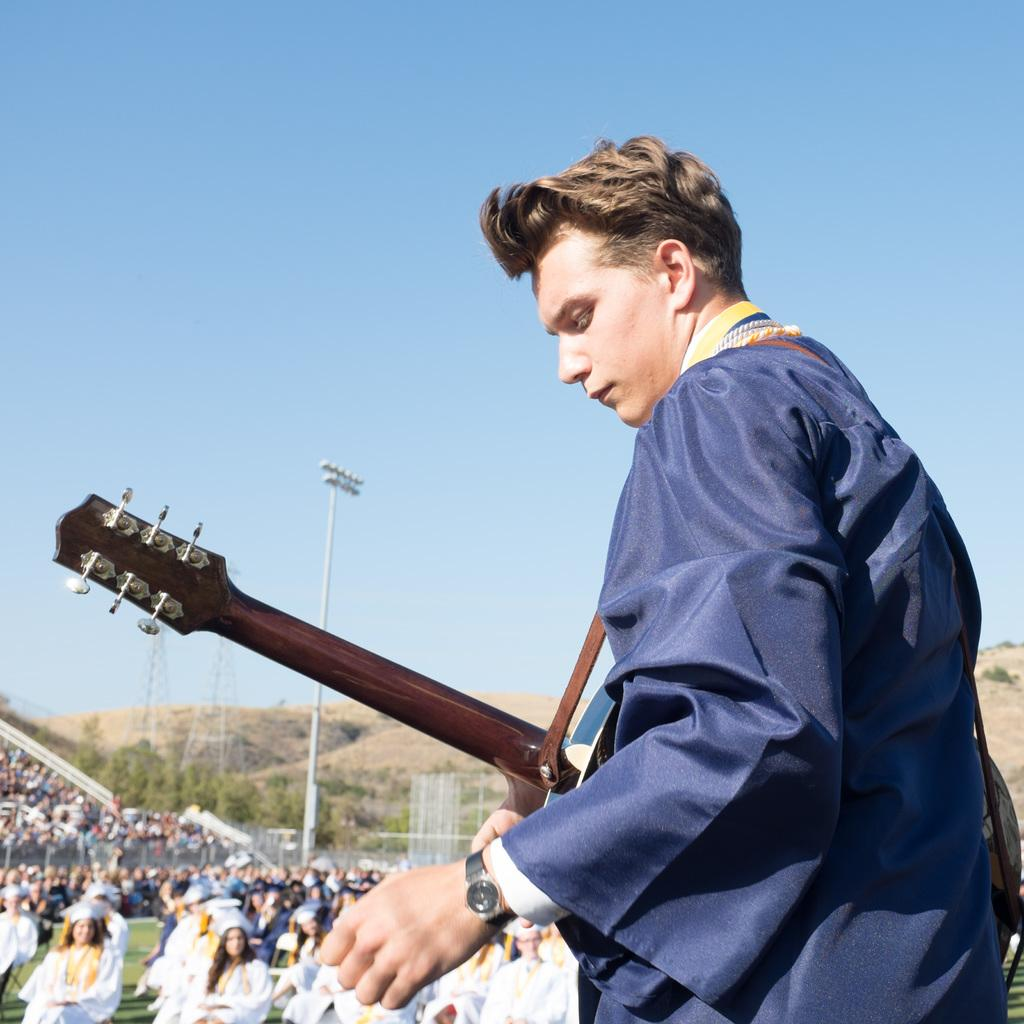What is the person in the image wearing? The person is wearing a blue dress in the image. What is the person holding in the image? The person is holding a guitar in the image. Who is present in front of the person? There is an audience in front of the person. What type of trade is being conducted in the image? There is no trade being conducted in the image; the image features a person holding a guitar in front of an audience. What day of the week is depicted in the image? The day of the week is not mentioned or depicted in the image. 